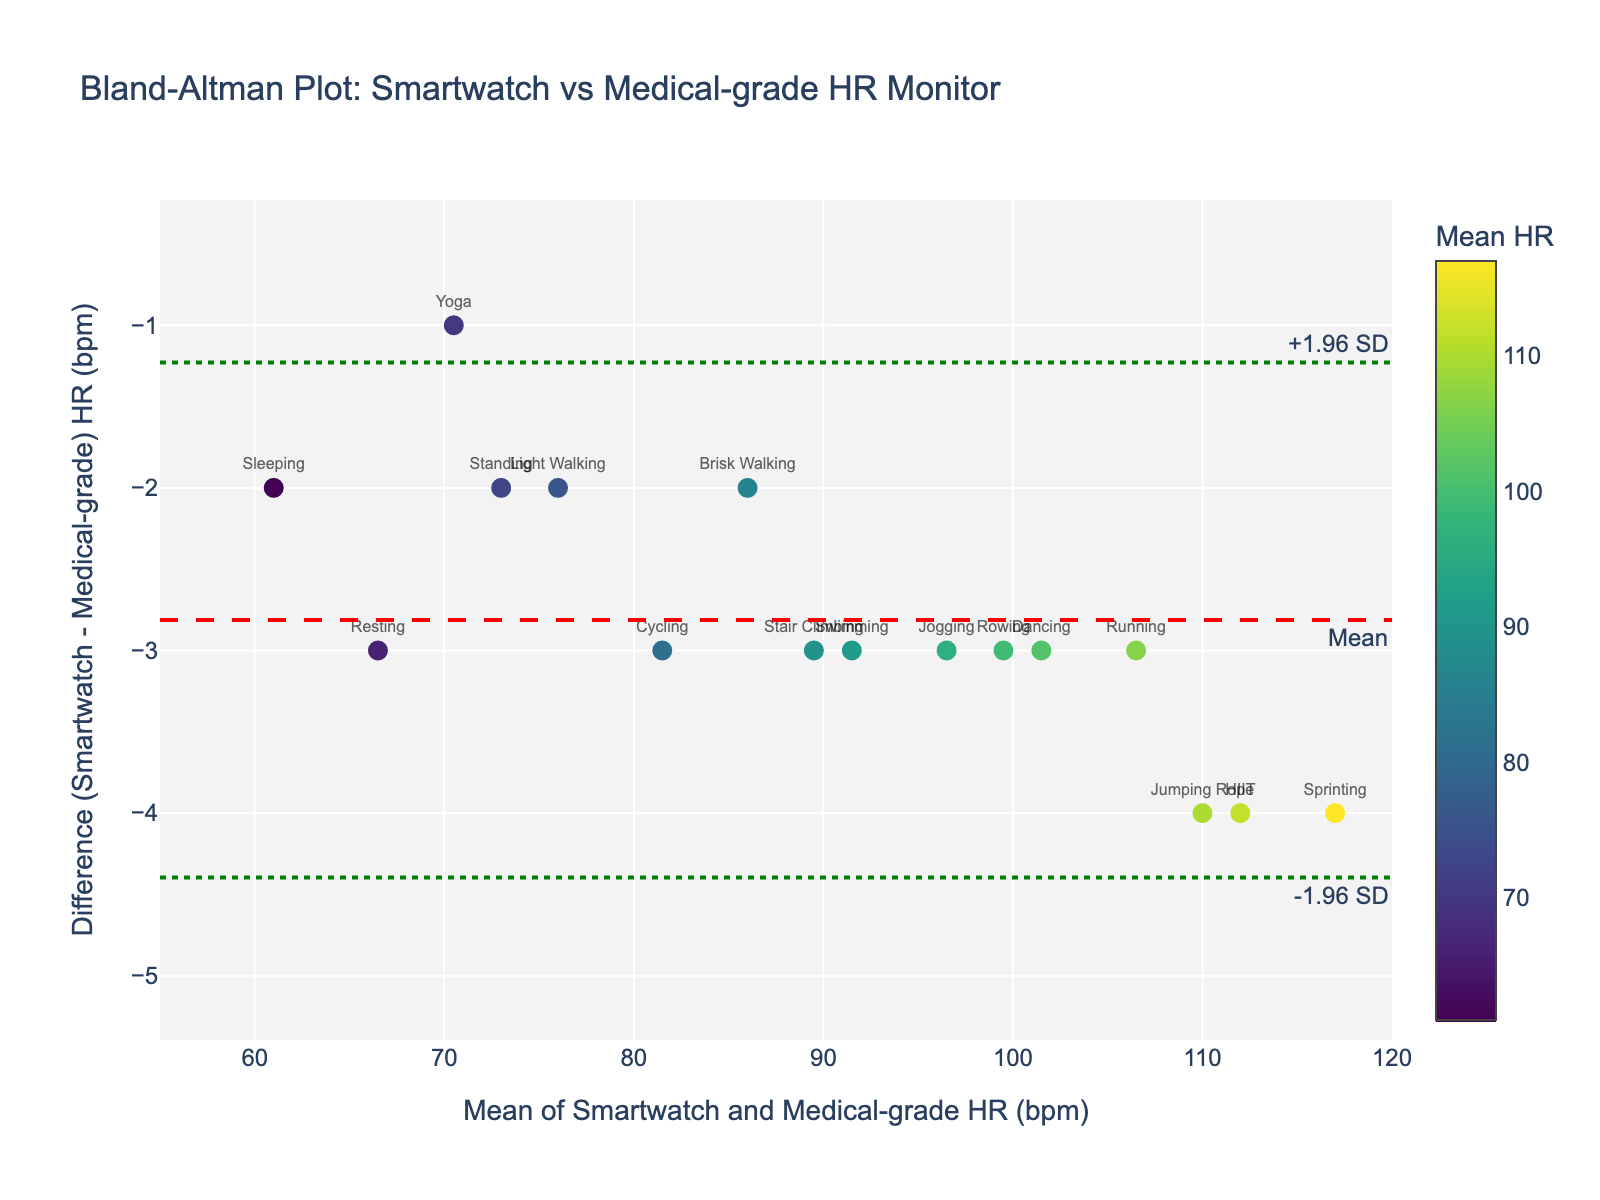What's the title of the plot? The title is usually displayed at the top of the plot. Here, it reads "Bland-Altman Plot: Smartwatch vs Medical-grade HR Monitor".
Answer: Bland-Altman Plot: Smartwatch vs Medical-grade HR Monitor What are the x-axis and y-axis titles? The x-axis and y-axis titles are labels that describe the data plotted along each axis. In this plot, the x-axis title is "Mean of Smartwatch and Medical-grade HR (bpm)" and the y-axis title is "Difference (Smartwatch - Medical-grade) HR (bpm)".
Answer: Mean of Smartwatch and Medical-grade HR (bpm); Difference (Smartwatch - Medical-grade) HR (bpm) How many data points are there on the plot? Each data point represents a pair of heart rate measurements from the smartwatch and medical-grade monitor. The total number of rows in the provided data (excluding the header) indicates the number of data points. There are 17 activities listed.
Answer: 17 Which activity shows the smallest difference between smartwatch and medical-grade heart rate? To find this, look at the y-coordinates (differences) labeled with activity levels. The activity with the smallest y-value (closest to zero but not negative) represents the smallest difference.
Answer: Yoga What is the mean difference line in the plot? The mean difference line is a horizontal line indicating the average difference between the smartwatch and medical-grade heart rates. It's usually labeled "Mean" and a dashed red line in this plot. It shows how much, on average, the smartwatch readings deviate from the medical-grade monitor.
Answer: Red dashed line labeled "Mean" What are the lower and upper limits of agreement? The limits of agreement are typically the dotted lines representing the mean difference ± 1.96 standard deviations. These lines highlight the range within which most differences are expected to lie. The lower limit is labeled "-1.96 SD" and the upper limit is "+1.96 SD".
Answer: Lower: -1.96 SD, Upper: +1.96 SD Which activity shows the largest positive difference in heart rates? Examine the y-coordinates for the activity levels to find the largest positive value. The activity at the highest y-value reflects the highest positive difference.
Answer: Sprinting Are any activity level differences outside the limits of agreement? Check if any data points (y-values) lie outside the range marked by the lower and upper limits of agreement, which are the green dotted lines. If any data points fall outside these lines, they are outside the limits of agreement.
Answer: No Which activity has the highest mean heart rate (x-value)? The x-coordinates represent the mean heart rate of each activity. Identify the data point with the highest x-value to find the activity with the highest mean heart rate.
Answer: Sprinting 